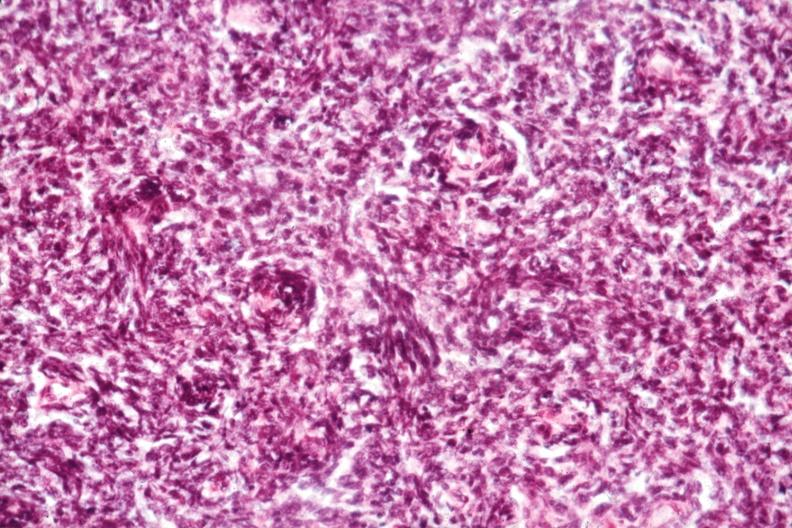s malignant thymoma present?
Answer the question using a single word or phrase. Yes 